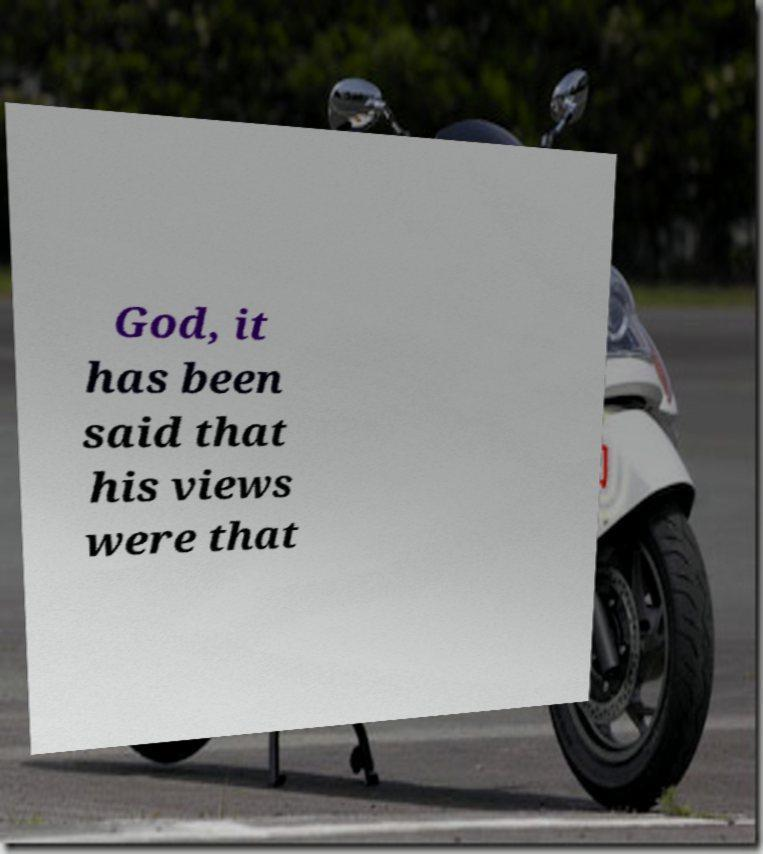What messages or text are displayed in this image? I need them in a readable, typed format. God, it has been said that his views were that 